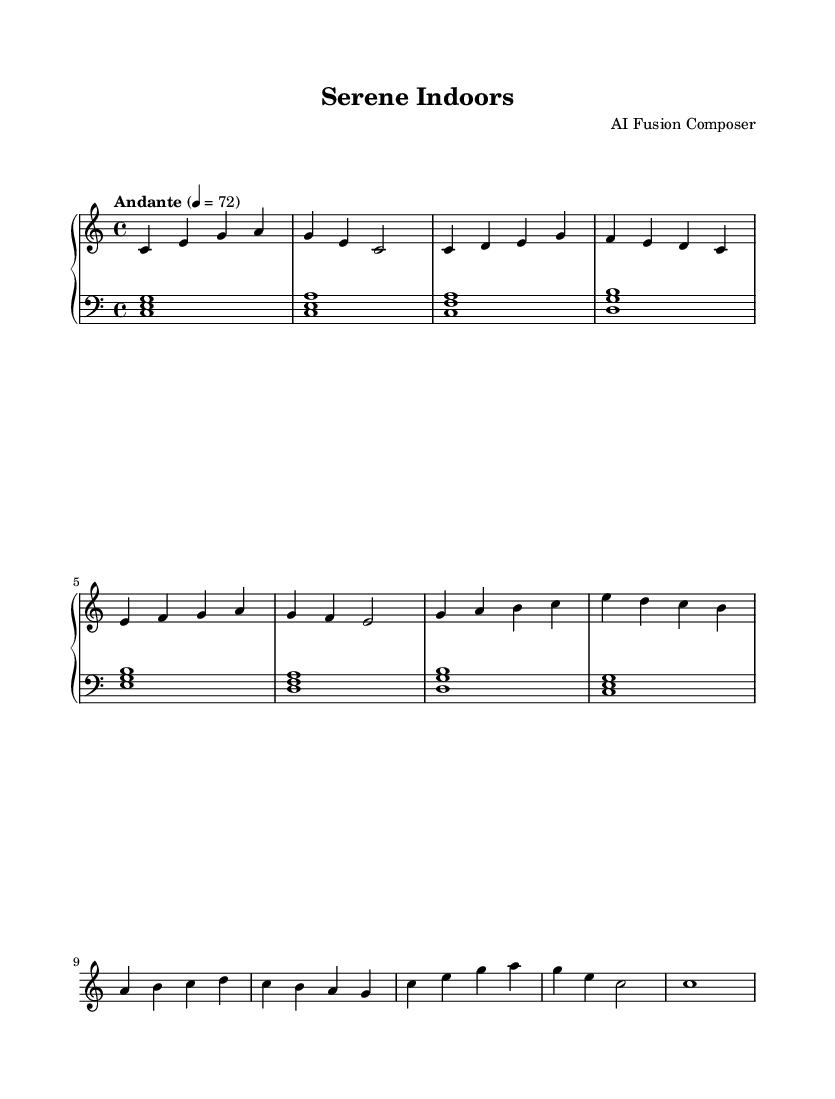What is the key signature of this music? The key signature appears at the beginning of the sheet music. In this case, it is C major, which has no sharps or flats visible.
Answer: C major What is the time signature of this music? The time signature is found next to the key signature at the beginning. It is indicated as 4/4, which means there are four beats in each measure and the quarter note gets one beat.
Answer: 4/4 What is the tempo marking of this music? The tempo marking is located above the staff, indicating how fast the music should be played. Here, it states "Andante" and is set to a metronome marking of 72 quarter notes per minute.
Answer: Andante How many measures are in the music? By counting the number of vertical bar lines on the sheet music, we can determine the number of measures. There are a total of eight measures present in the provided score.
Answer: Eight What is the structure of the music based on the sections labeled in the sheet? The structure indicates different sections: it starts with an Intro, followed by a Verse, then a Chorus, and ends with an Outro, showing a clear progression through various segments.
Answer: Intro, Verse, Chorus, Outro What is the highest note played in this piece? To identify the highest note, we look at the topmost note in the music notation. The highest note in this piece is B, which appears in the Chorus section.
Answer: B What type of fusion elements are present in this piece? The music combines elements of electronic and classical styles, as indicated by the piano scoring typical of classical compositions, while the overall style and harmonics are influenced by the relaxing qualities of electronic music.
Answer: Electronic and classical 